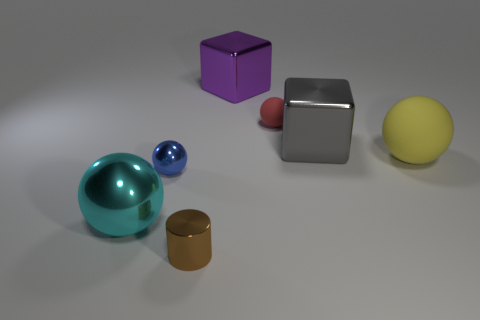Is there anything else that has the same color as the large rubber object?
Provide a succinct answer. No. What shape is the purple thing that is the same material as the tiny blue sphere?
Offer a very short reply. Cube. Does the big thing that is in front of the blue object have the same material as the small brown object?
Make the answer very short. Yes. Does the large sphere on the right side of the big cyan metal object have the same color as the small matte thing to the left of the yellow matte object?
Give a very brief answer. No. What number of balls are left of the yellow matte thing and behind the tiny blue sphere?
Keep it short and to the point. 1. What material is the small cylinder?
Offer a terse response. Metal. What is the shape of the brown shiny thing that is the same size as the red rubber ball?
Offer a terse response. Cylinder. Are the tiny thing that is right of the tiny shiny cylinder and the cube to the left of the red thing made of the same material?
Keep it short and to the point. No. What number of green matte things are there?
Provide a short and direct response. 0. How many blue things have the same shape as the big yellow rubber object?
Ensure brevity in your answer.  1. 